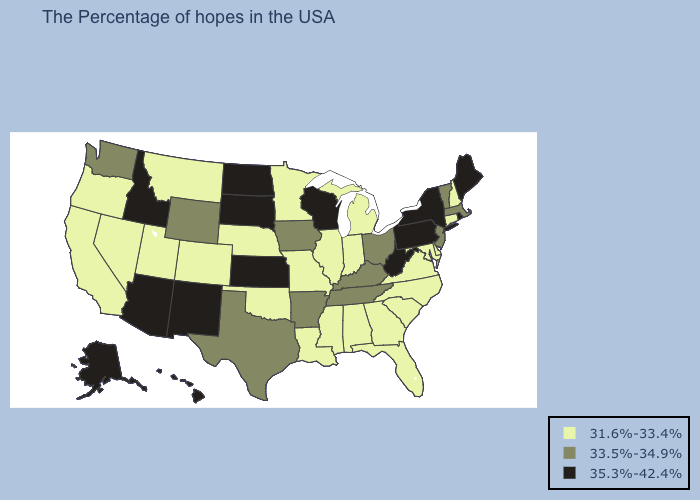What is the lowest value in states that border Rhode Island?
Quick response, please. 31.6%-33.4%. What is the lowest value in the West?
Concise answer only. 31.6%-33.4%. Name the states that have a value in the range 35.3%-42.4%?
Write a very short answer. Maine, Rhode Island, New York, Pennsylvania, West Virginia, Wisconsin, Kansas, South Dakota, North Dakota, New Mexico, Arizona, Idaho, Alaska, Hawaii. Name the states that have a value in the range 33.5%-34.9%?
Give a very brief answer. Massachusetts, Vermont, New Jersey, Ohio, Kentucky, Tennessee, Arkansas, Iowa, Texas, Wyoming, Washington. Name the states that have a value in the range 35.3%-42.4%?
Give a very brief answer. Maine, Rhode Island, New York, Pennsylvania, West Virginia, Wisconsin, Kansas, South Dakota, North Dakota, New Mexico, Arizona, Idaho, Alaska, Hawaii. Among the states that border Nebraska , which have the lowest value?
Write a very short answer. Missouri, Colorado. Does West Virginia have the highest value in the South?
Quick response, please. Yes. Does South Dakota have the lowest value in the USA?
Quick response, please. No. Does Massachusetts have the same value as Iowa?
Keep it brief. Yes. What is the lowest value in the South?
Concise answer only. 31.6%-33.4%. Among the states that border New York , which have the lowest value?
Quick response, please. Connecticut. Name the states that have a value in the range 31.6%-33.4%?
Be succinct. New Hampshire, Connecticut, Delaware, Maryland, Virginia, North Carolina, South Carolina, Florida, Georgia, Michigan, Indiana, Alabama, Illinois, Mississippi, Louisiana, Missouri, Minnesota, Nebraska, Oklahoma, Colorado, Utah, Montana, Nevada, California, Oregon. What is the value of Ohio?
Keep it brief. 33.5%-34.9%. What is the value of Arkansas?
Short answer required. 33.5%-34.9%. Is the legend a continuous bar?
Concise answer only. No. 